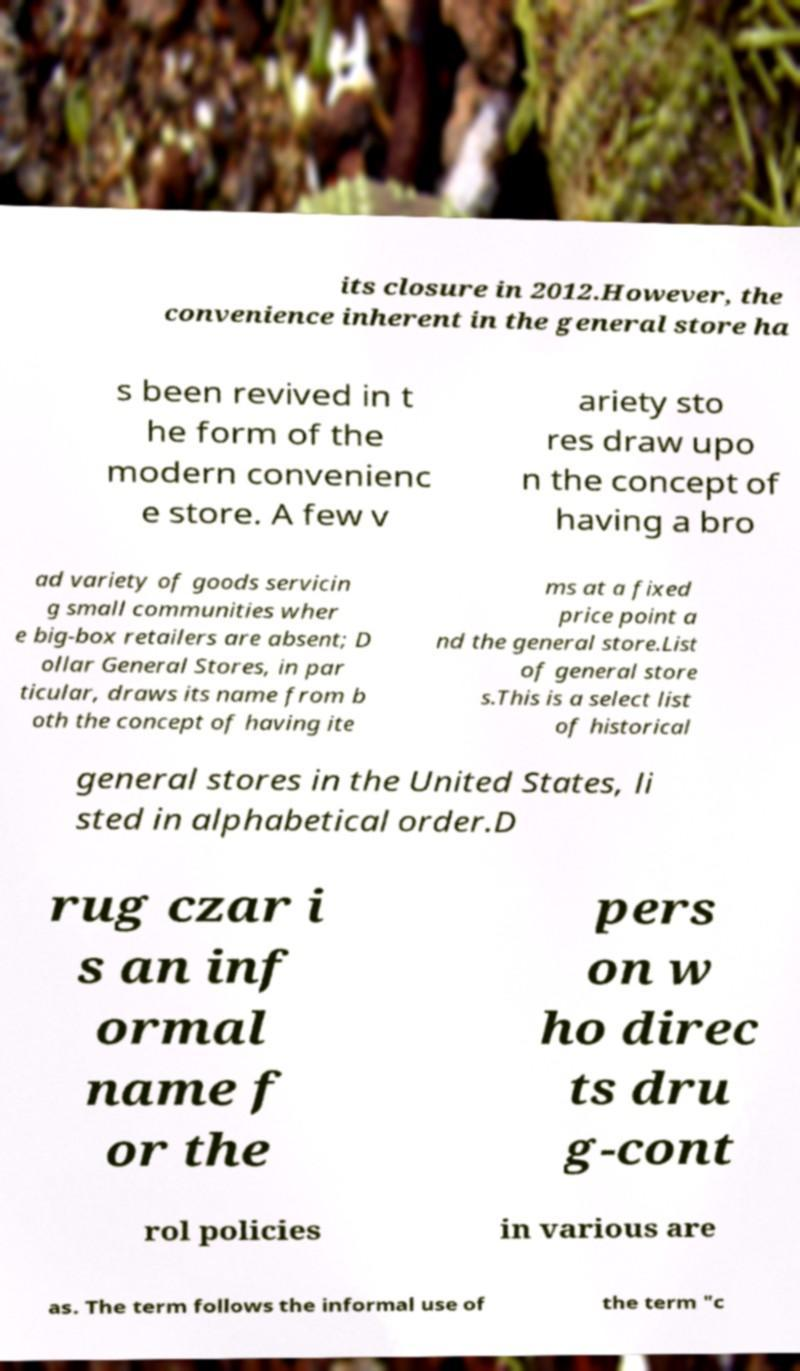Can you read and provide the text displayed in the image?This photo seems to have some interesting text. Can you extract and type it out for me? its closure in 2012.However, the convenience inherent in the general store ha s been revived in t he form of the modern convenienc e store. A few v ariety sto res draw upo n the concept of having a bro ad variety of goods servicin g small communities wher e big-box retailers are absent; D ollar General Stores, in par ticular, draws its name from b oth the concept of having ite ms at a fixed price point a nd the general store.List of general store s.This is a select list of historical general stores in the United States, li sted in alphabetical order.D rug czar i s an inf ormal name f or the pers on w ho direc ts dru g-cont rol policies in various are as. The term follows the informal use of the term "c 